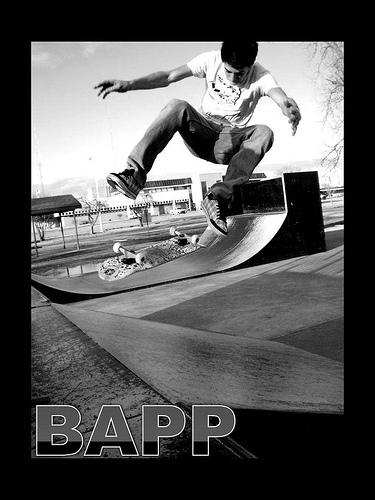World skate is the head controller of which sport? Please explain your reasoning. skating. World skate is the governing body for roller sports. 